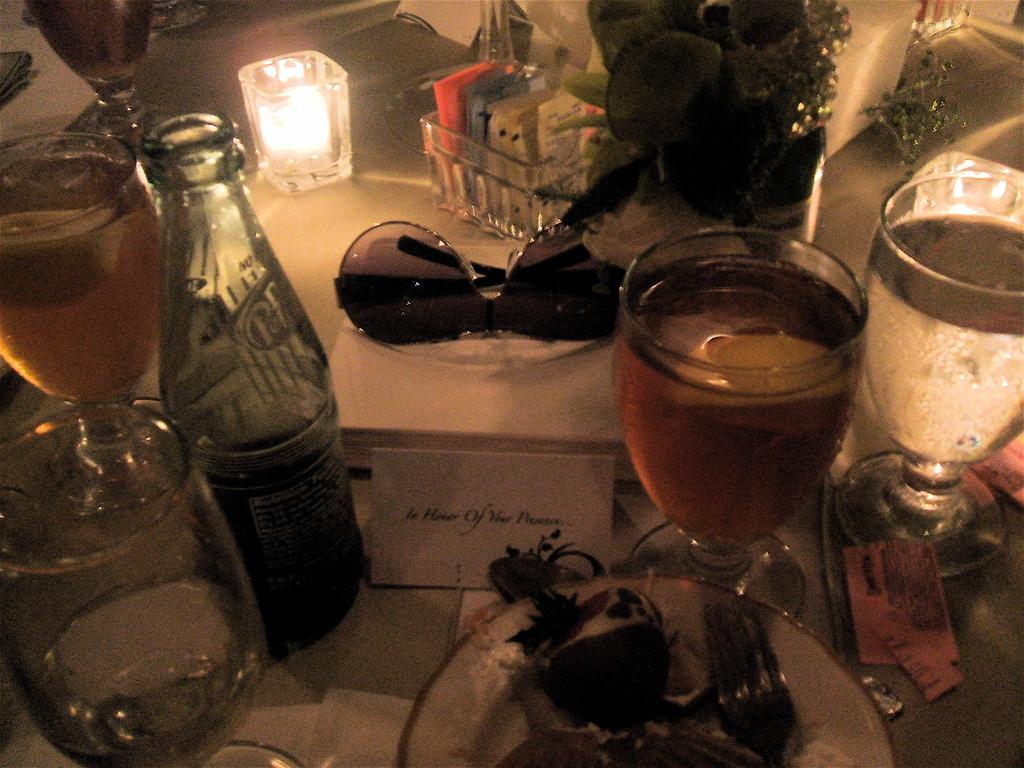What type of containers are visible in the image? There are glass bottles in the image. What else can be seen on the table in the image? There are other objects on the table in the image, but their specific details are not provided. How many mice are pulling the glass bottles in the image? There are no mice present in the image, and the glass bottles are not being pulled by any animals. 